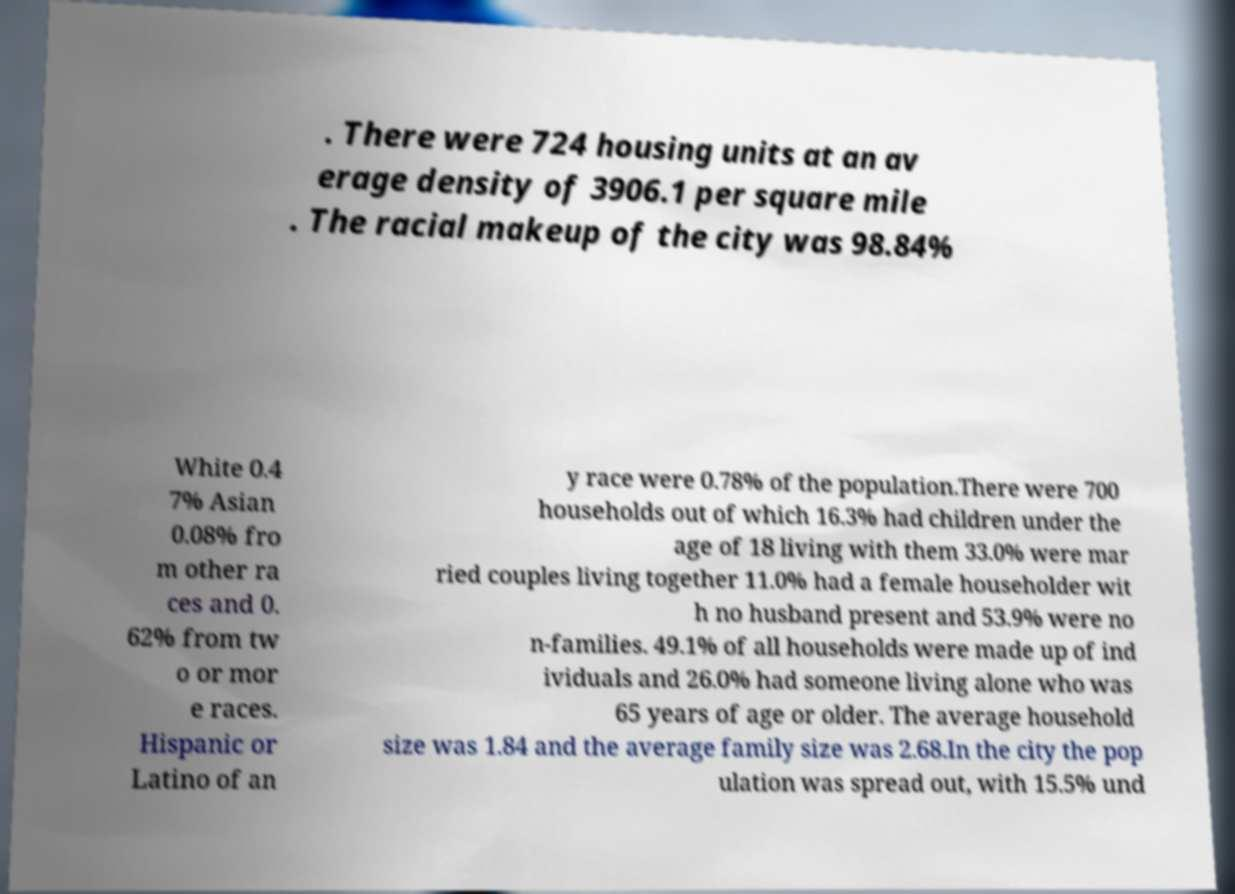I need the written content from this picture converted into text. Can you do that? . There were 724 housing units at an av erage density of 3906.1 per square mile . The racial makeup of the city was 98.84% White 0.4 7% Asian 0.08% fro m other ra ces and 0. 62% from tw o or mor e races. Hispanic or Latino of an y race were 0.78% of the population.There were 700 households out of which 16.3% had children under the age of 18 living with them 33.0% were mar ried couples living together 11.0% had a female householder wit h no husband present and 53.9% were no n-families. 49.1% of all households were made up of ind ividuals and 26.0% had someone living alone who was 65 years of age or older. The average household size was 1.84 and the average family size was 2.68.In the city the pop ulation was spread out, with 15.5% und 